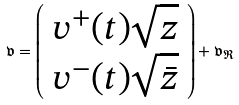<formula> <loc_0><loc_0><loc_500><loc_500>\mathfrak { v } = \left ( \begin{array} { c } v ^ { + } ( t ) \sqrt { z } \\ v ^ { - } ( t ) \sqrt { \bar { z } } \end{array} \right ) + \mathfrak { v } _ { \mathfrak { R } }</formula> 